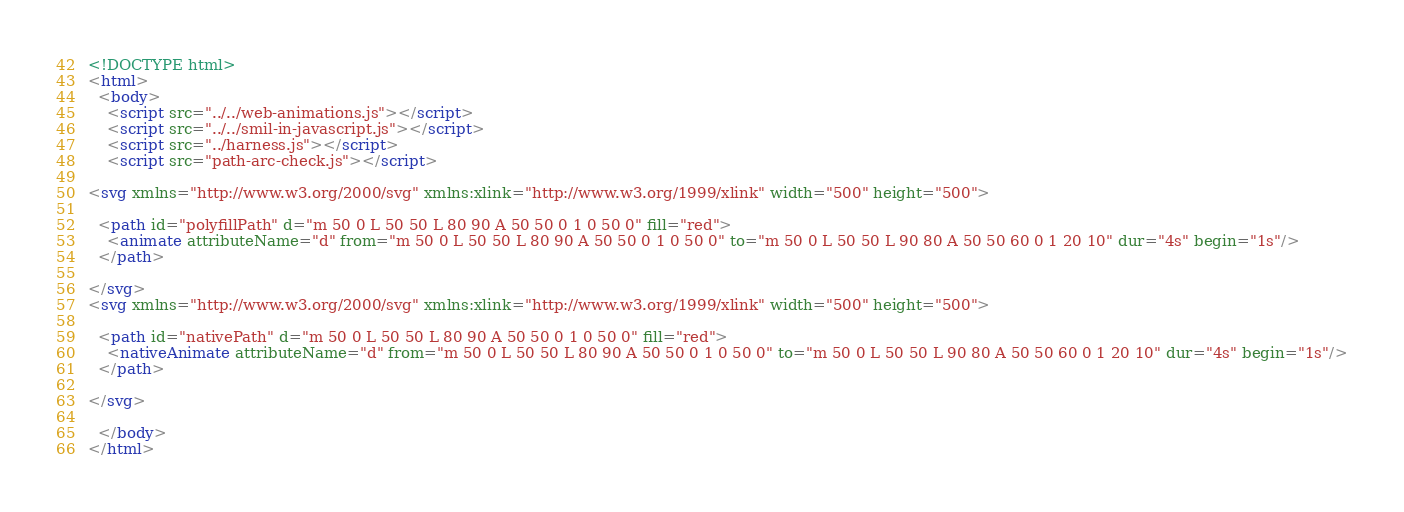Convert code to text. <code><loc_0><loc_0><loc_500><loc_500><_HTML_><!DOCTYPE html>
<html>
  <body>
    <script src="../../web-animations.js"></script>
    <script src="../../smil-in-javascript.js"></script>
    <script src="../harness.js"></script>
    <script src="path-arc-check.js"></script>

<svg xmlns="http://www.w3.org/2000/svg" xmlns:xlink="http://www.w3.org/1999/xlink" width="500" height="500">

  <path id="polyfillPath" d="m 50 0 L 50 50 L 80 90 A 50 50 0 1 0 50 0" fill="red">
    <animate attributeName="d" from="m 50 0 L 50 50 L 80 90 A 50 50 0 1 0 50 0" to="m 50 0 L 50 50 L 90 80 A 50 50 60 0 1 20 10" dur="4s" begin="1s"/>
  </path>

</svg>
<svg xmlns="http://www.w3.org/2000/svg" xmlns:xlink="http://www.w3.org/1999/xlink" width="500" height="500">

  <path id="nativePath" d="m 50 0 L 50 50 L 80 90 A 50 50 0 1 0 50 0" fill="red">
    <nativeAnimate attributeName="d" from="m 50 0 L 50 50 L 80 90 A 50 50 0 1 0 50 0" to="m 50 0 L 50 50 L 90 80 A 50 50 60 0 1 20 10" dur="4s" begin="1s"/>
  </path>

</svg>

  </body>
</html>
</code> 